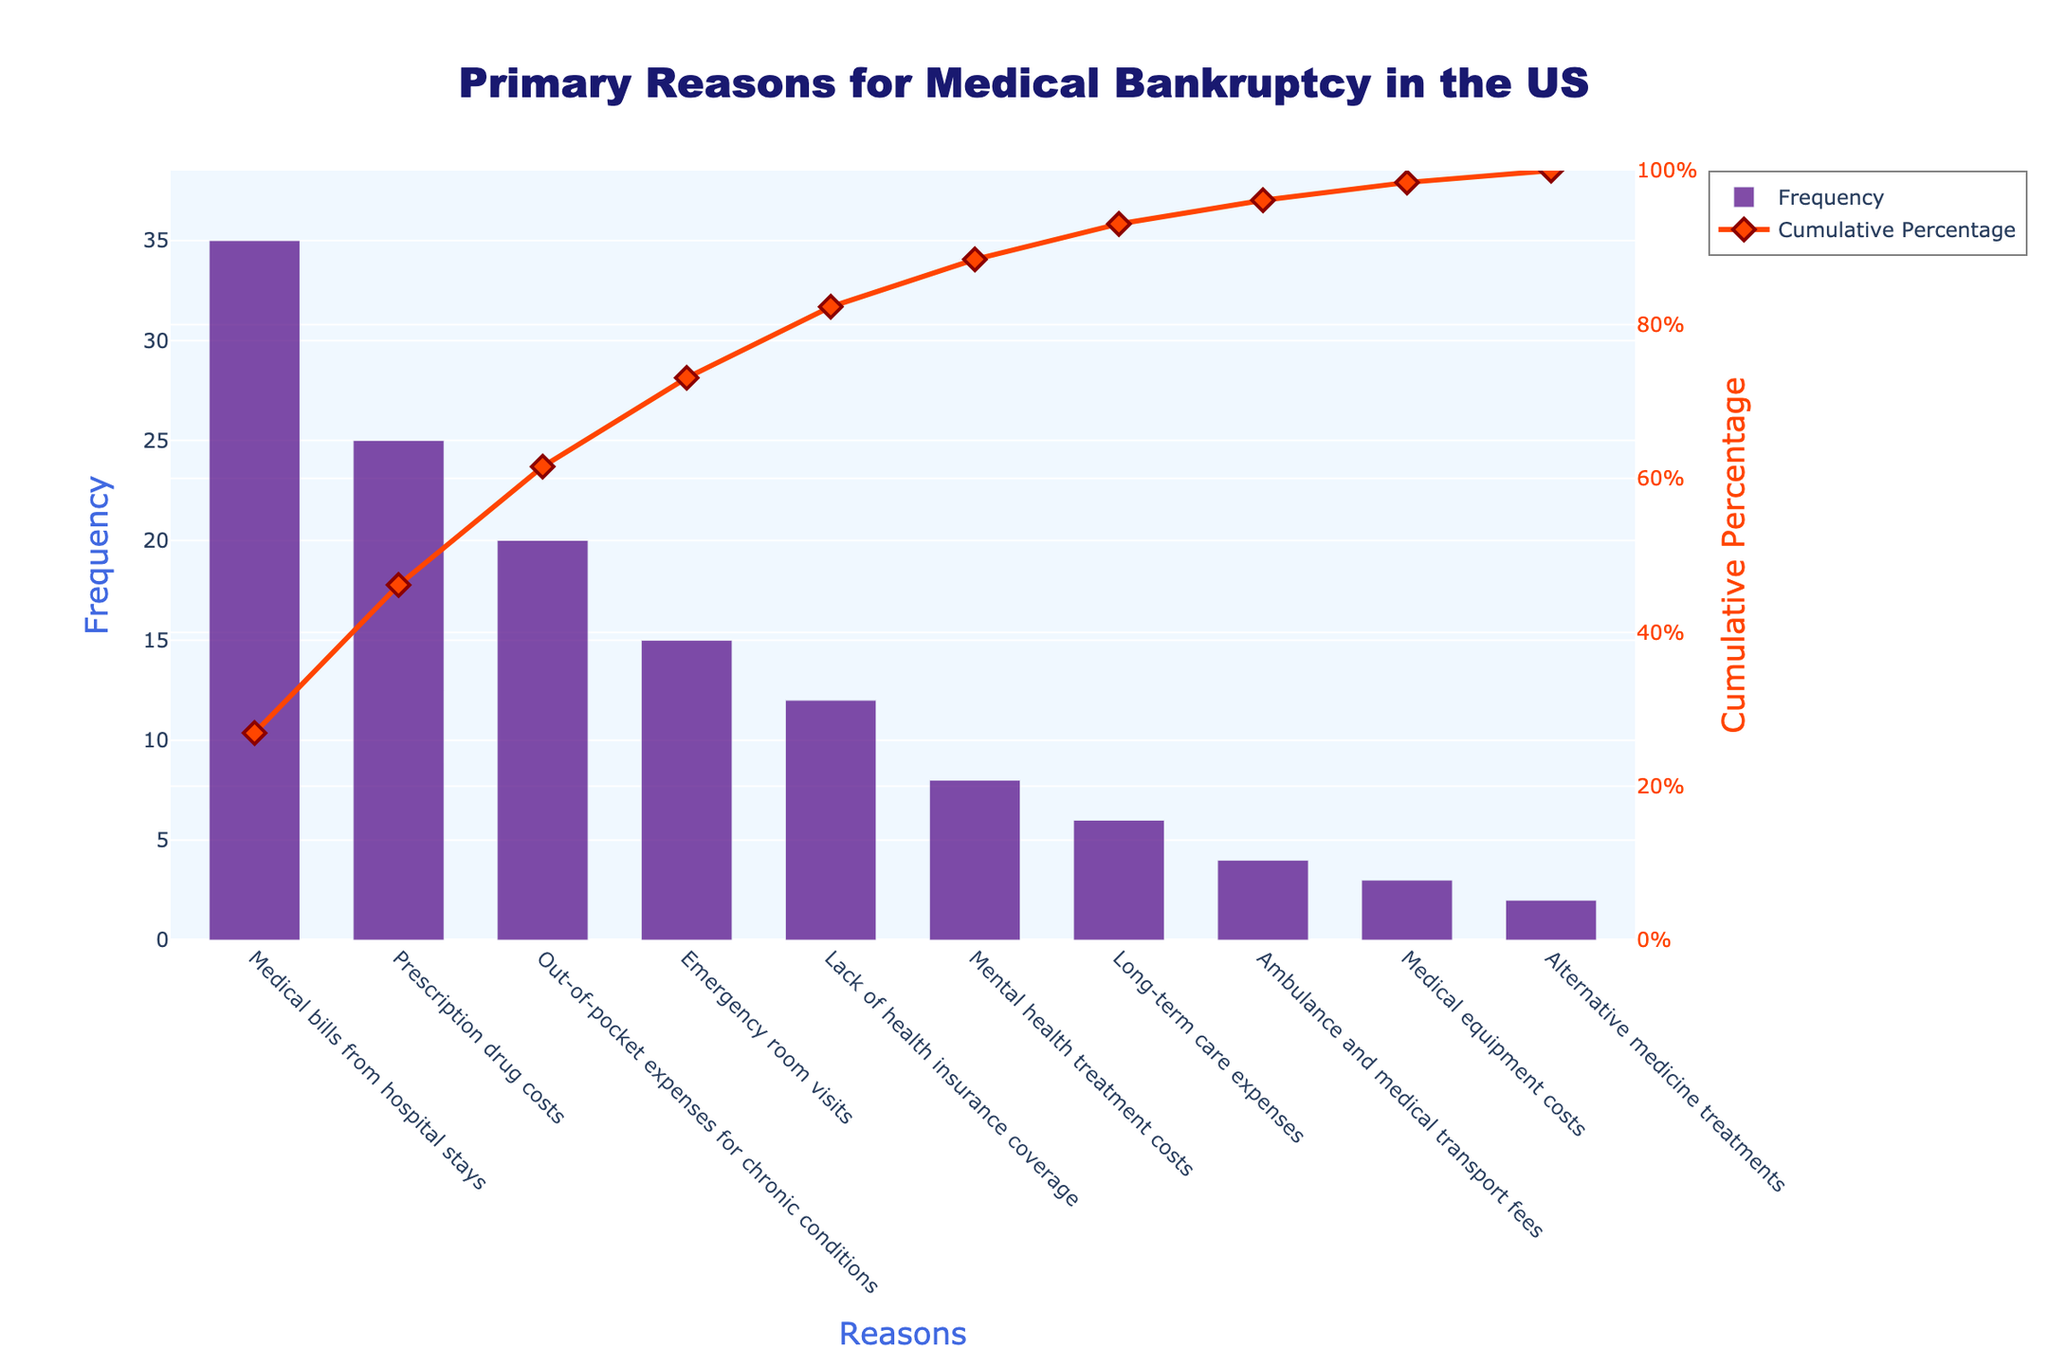What is the title of the chart? The title of the chart is displayed prominently at the top and reads 'Primary Reasons for Medical Bankruptcy in the US.'
Answer: Primary Reasons for Medical Bankruptcy in the US What is the primary reason for medical bankruptcy according to the chart? The primary reason is the one with the highest bar in the chart, labeled 'Medical bills from hospital stays.'
Answer: Medical bills from hospital stays How many reasons are listed in total? The total number of reasons can be counted by the number of bars in the chart.
Answer: 10 Which reason has a higher frequency: 'Emergency room visits' or 'Lack of health insurance coverage'? By comparing the heights of the bars for 'Emergency room visits' and 'Lack of health insurance coverage,' we see that 'Emergency room visits' has a higher frequency.
Answer: Emergency room visits What is the cumulative percentage up to the first 3 reasons? Add the cumulative percentages up to the first 3 reasons on the line plot. For 'Medical bills from hospital stays', 'Prescription drug costs', and 'Out-of-pocket expenses for chronic conditions,' the cumulative percentages sum as follows: 35/130*100 + 25/130*100 + 20/130*100 = roughly 59.23%.
Answer: 59.23% How does the frequency of 'Mental health treatment costs' compare to 'Long-term care expenses'? By looking at the heights of the bars, we see that 'Mental health treatment costs' has a slightly higher frequency than 'Long-term care expenses.'
Answer: Mental health treatment costs What is the cumulative percentage when 'Emergency room visits' is included? Sum the cumulative percentages of the first 4 reasons: 35 + 25 + 20 + 15 = 95 out of a total of 130, giving us (95/130*100) roughly 73.08%.
Answer: 73.08% Which three reasons contribute the least to medical bankruptcies according to the chart? The three reasons with the smallest bars are 'Ambulance and medical transport fees,' 'Medical equipment costs,' and 'Alternative medicine treatments.'
Answer: Ambulance and medical transport fees, Medical equipment costs, Alternative medicine treatments What percentage of the total do 'Prescription drug costs' and 'Out-of-pocket expenses for chronic conditions' together contribute? Add the frequencies of 'Prescription drug costs' (25) and 'Out-of-pocket expenses for chronic conditions' (20), then divide by the total (130) and multiply by 100 to get the percentage. (25 + 20) / 130 * 100 = roughly 34.62%.
Answer: 34.62% How does the bar color compare to the line color? The bar color is a shade of purple, while the line color is a distinct orange, making them visually separate.
Answer: Purple and orange 